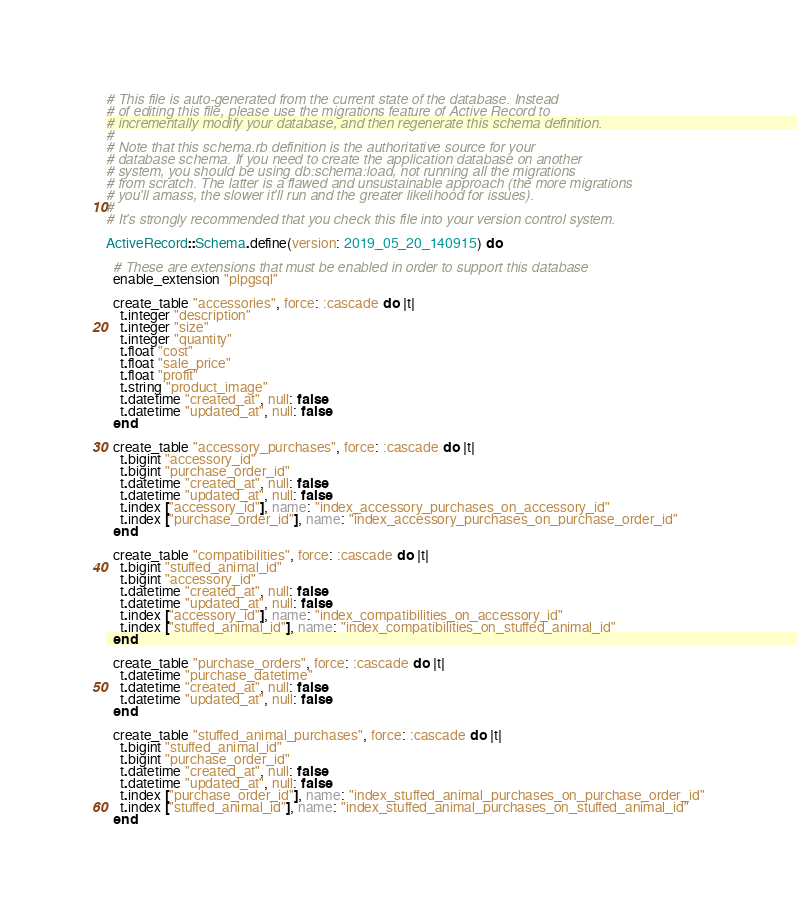<code> <loc_0><loc_0><loc_500><loc_500><_Ruby_># This file is auto-generated from the current state of the database. Instead
# of editing this file, please use the migrations feature of Active Record to
# incrementally modify your database, and then regenerate this schema definition.
#
# Note that this schema.rb definition is the authoritative source for your
# database schema. If you need to create the application database on another
# system, you should be using db:schema:load, not running all the migrations
# from scratch. The latter is a flawed and unsustainable approach (the more migrations
# you'll amass, the slower it'll run and the greater likelihood for issues).
#
# It's strongly recommended that you check this file into your version control system.

ActiveRecord::Schema.define(version: 2019_05_20_140915) do

  # These are extensions that must be enabled in order to support this database
  enable_extension "plpgsql"

  create_table "accessories", force: :cascade do |t|
    t.integer "description"
    t.integer "size"
    t.integer "quantity"
    t.float "cost"
    t.float "sale_price"
    t.float "profit"
    t.string "product_image"
    t.datetime "created_at", null: false
    t.datetime "updated_at", null: false
  end

  create_table "accessory_purchases", force: :cascade do |t|
    t.bigint "accessory_id"
    t.bigint "purchase_order_id"
    t.datetime "created_at", null: false
    t.datetime "updated_at", null: false
    t.index ["accessory_id"], name: "index_accessory_purchases_on_accessory_id"
    t.index ["purchase_order_id"], name: "index_accessory_purchases_on_purchase_order_id"
  end

  create_table "compatibilities", force: :cascade do |t|
    t.bigint "stuffed_animal_id"
    t.bigint "accessory_id"
    t.datetime "created_at", null: false
    t.datetime "updated_at", null: false
    t.index ["accessory_id"], name: "index_compatibilities_on_accessory_id"
    t.index ["stuffed_animal_id"], name: "index_compatibilities_on_stuffed_animal_id"
  end

  create_table "purchase_orders", force: :cascade do |t|
    t.datetime "purchase_datetime"
    t.datetime "created_at", null: false
    t.datetime "updated_at", null: false
  end

  create_table "stuffed_animal_purchases", force: :cascade do |t|
    t.bigint "stuffed_animal_id"
    t.bigint "purchase_order_id"
    t.datetime "created_at", null: false
    t.datetime "updated_at", null: false
    t.index ["purchase_order_id"], name: "index_stuffed_animal_purchases_on_purchase_order_id"
    t.index ["stuffed_animal_id"], name: "index_stuffed_animal_purchases_on_stuffed_animal_id"
  end
</code> 